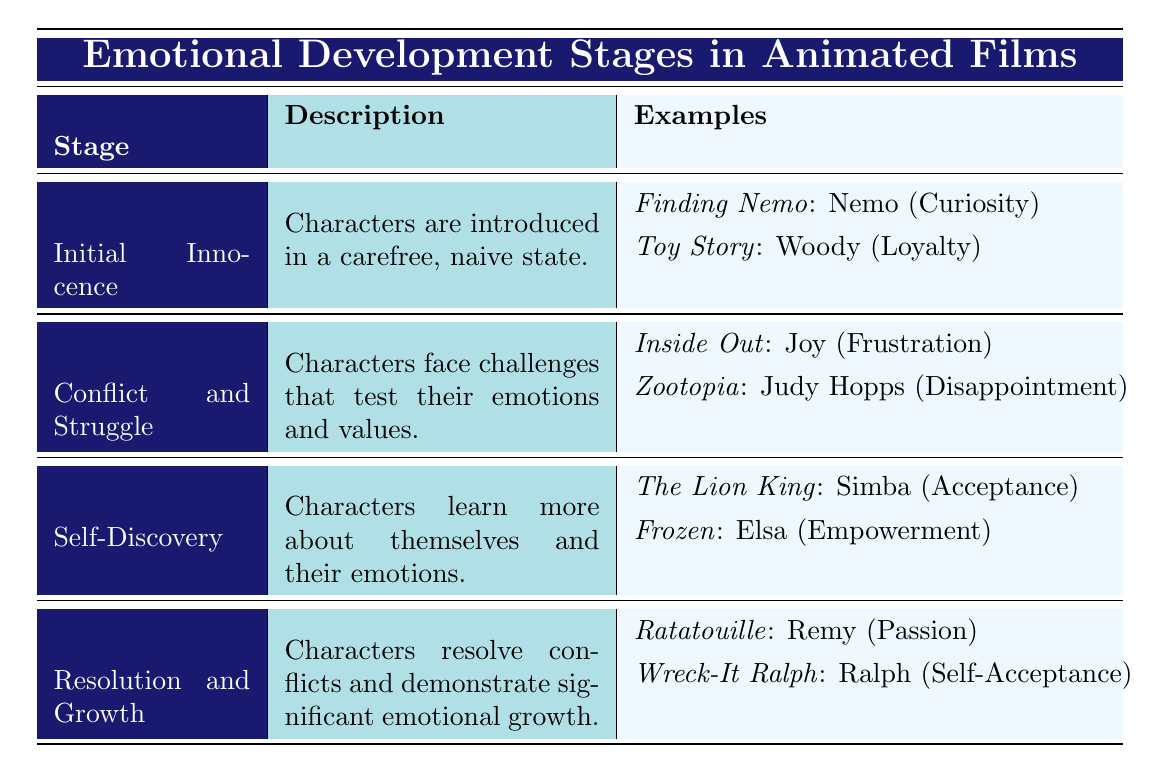What is the name of Stage 3 in the emotional development stages? The table lists the stages with their corresponding names. Stage 3 is labeled as "Self-Discovery."
Answer: Self-Discovery Name one character from the "Resolution and Growth" stage and their emotion. The table indicates that in the "Resolution and Growth" stage, one character is Remy from "Ratatouille," who expresses the emotion of "Passion."
Answer: Remy (Passion) How many stages are listed in the emotional development stages? The table outlines four distinct stages: Initial Innocence, Conflict and Struggle, Self-Discovery, and Resolution and Growth. Thus, there are a total of four stages.
Answer: Four Is "Curiosity" the emotion associated with the character Nemo? By checking the table, it shows that Nemo from "Finding Nemo" indeed represents the emotion of "Curiosity" in the Initial Innocence stage.
Answer: Yes Which character in the "Conflict and Struggle" stage experiences "Disappointment"? In the Conflict and Struggle stage, the table identifies Judy Hopps from "Zootopia," who experiences "Disappointment."
Answer: Judy Hopps What is the average number of emotions expressed by characters across all stages? Each stage has two characters demonstrating emotions. Therefore, the total number of characters is 4 stages * 2 characters = 8 characters. Consequently, the average number of emotions is 8/4 stages = 2.
Answer: 2 Are there more characters associated with the "Self-Discovery" stage than the "Initial Innocence" stage? Both the "Self-Discovery" and "Initial Innocence" stages have two characters listed each, indicating that they have the same number of characters associated with them.
Answer: No Which emotional development stage features a character learning about "Acceptance"? The table indicates that Simba from "The Lion King" learns about "Acceptance" in the "Self-Discovery" stage.
Answer: Self-Discovery 